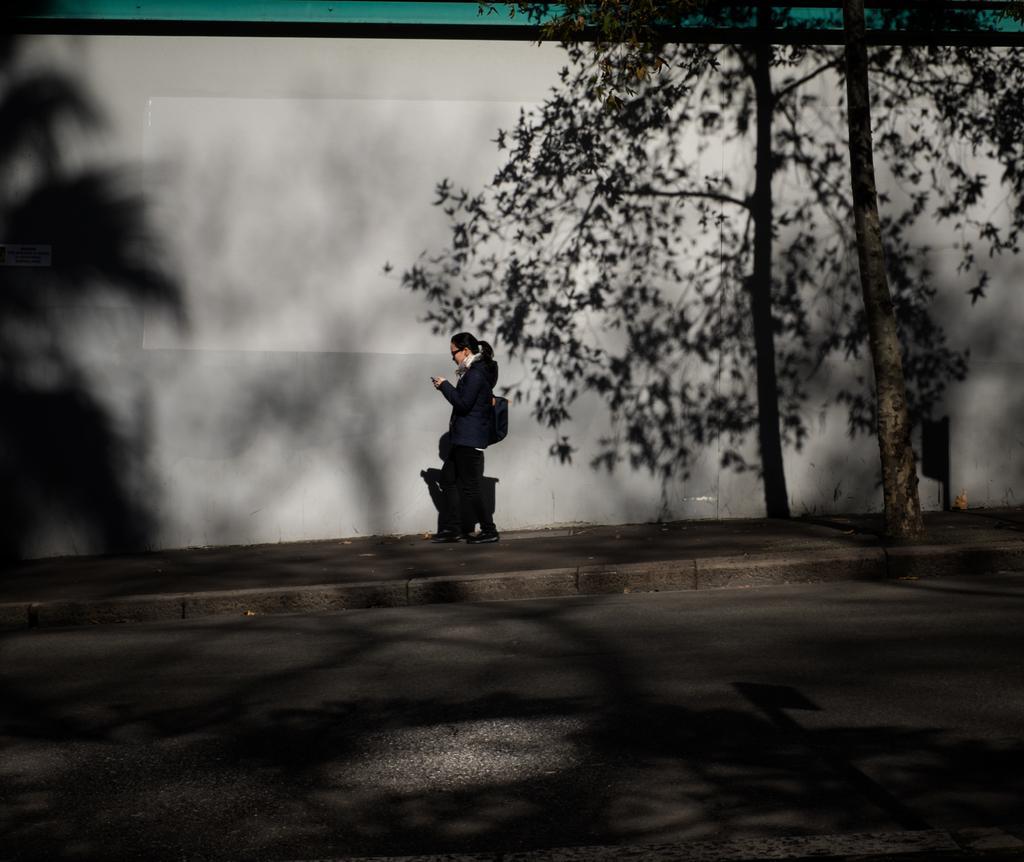Can you describe this image briefly? In the image there is a woman in suit holding a cellphone and walking on the footpath, on the right side there is a tree and in front its road, beside her its a wall. 